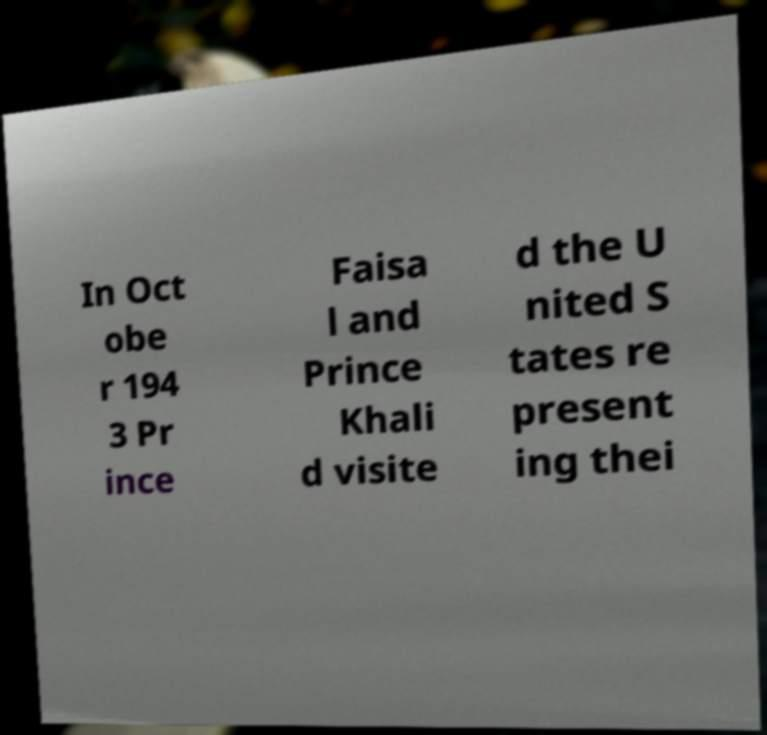For documentation purposes, I need the text within this image transcribed. Could you provide that? In Oct obe r 194 3 Pr ince Faisa l and Prince Khali d visite d the U nited S tates re present ing thei 